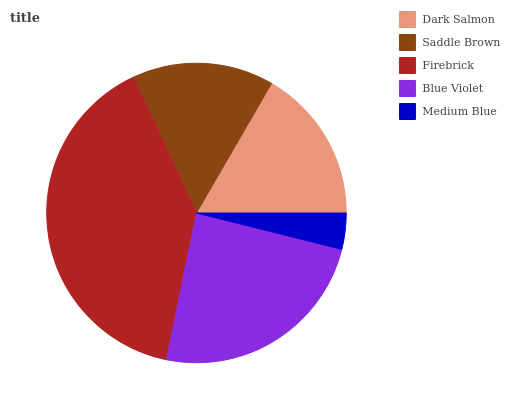Is Medium Blue the minimum?
Answer yes or no. Yes. Is Firebrick the maximum?
Answer yes or no. Yes. Is Saddle Brown the minimum?
Answer yes or no. No. Is Saddle Brown the maximum?
Answer yes or no. No. Is Dark Salmon greater than Saddle Brown?
Answer yes or no. Yes. Is Saddle Brown less than Dark Salmon?
Answer yes or no. Yes. Is Saddle Brown greater than Dark Salmon?
Answer yes or no. No. Is Dark Salmon less than Saddle Brown?
Answer yes or no. No. Is Dark Salmon the high median?
Answer yes or no. Yes. Is Dark Salmon the low median?
Answer yes or no. Yes. Is Medium Blue the high median?
Answer yes or no. No. Is Blue Violet the low median?
Answer yes or no. No. 